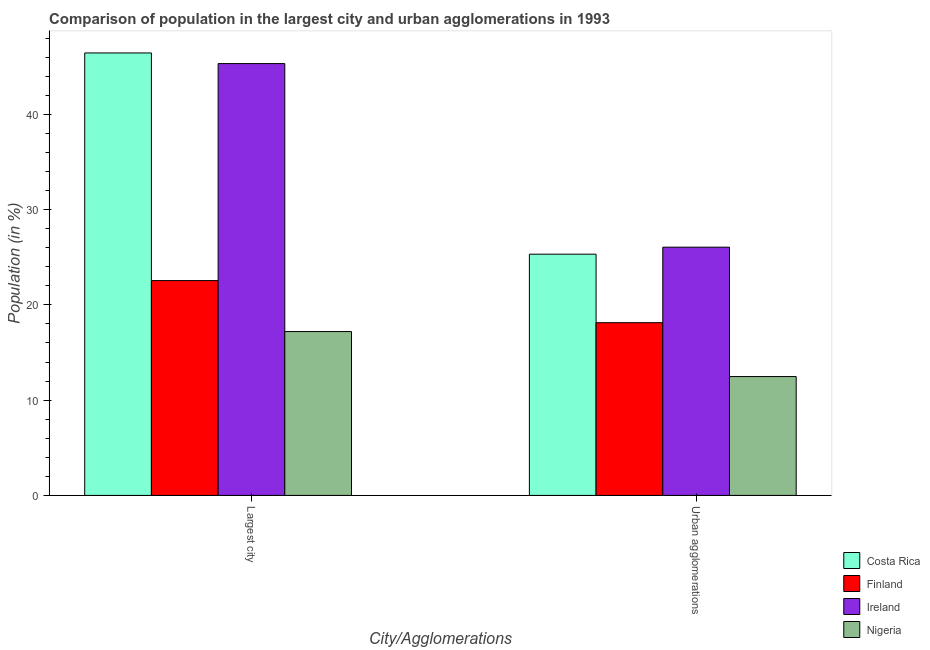How many different coloured bars are there?
Your answer should be very brief. 4. How many groups of bars are there?
Your response must be concise. 2. Are the number of bars on each tick of the X-axis equal?
Offer a very short reply. Yes. How many bars are there on the 1st tick from the right?
Keep it short and to the point. 4. What is the label of the 1st group of bars from the left?
Keep it short and to the point. Largest city. What is the population in urban agglomerations in Ireland?
Provide a short and direct response. 26.05. Across all countries, what is the maximum population in the largest city?
Ensure brevity in your answer.  46.43. Across all countries, what is the minimum population in urban agglomerations?
Make the answer very short. 12.47. In which country was the population in urban agglomerations maximum?
Your response must be concise. Ireland. In which country was the population in urban agglomerations minimum?
Provide a short and direct response. Nigeria. What is the total population in the largest city in the graph?
Give a very brief answer. 131.5. What is the difference between the population in the largest city in Costa Rica and that in Ireland?
Offer a terse response. 1.12. What is the difference between the population in urban agglomerations in Costa Rica and the population in the largest city in Nigeria?
Ensure brevity in your answer.  8.12. What is the average population in the largest city per country?
Offer a very short reply. 32.87. What is the difference between the population in the largest city and population in urban agglomerations in Ireland?
Your answer should be compact. 19.27. What is the ratio of the population in the largest city in Ireland to that in Nigeria?
Your answer should be compact. 2.64. In how many countries, is the population in the largest city greater than the average population in the largest city taken over all countries?
Provide a succinct answer. 2. What does the 4th bar from the left in Largest city represents?
Make the answer very short. Nigeria. What does the 4th bar from the right in Largest city represents?
Ensure brevity in your answer.  Costa Rica. Are all the bars in the graph horizontal?
Your answer should be very brief. No. What is the difference between two consecutive major ticks on the Y-axis?
Your response must be concise. 10. Does the graph contain grids?
Give a very brief answer. No. Where does the legend appear in the graph?
Your answer should be compact. Bottom right. How many legend labels are there?
Provide a succinct answer. 4. How are the legend labels stacked?
Your response must be concise. Vertical. What is the title of the graph?
Provide a succinct answer. Comparison of population in the largest city and urban agglomerations in 1993. What is the label or title of the X-axis?
Your response must be concise. City/Agglomerations. What is the label or title of the Y-axis?
Give a very brief answer. Population (in %). What is the Population (in %) in Costa Rica in Largest city?
Provide a succinct answer. 46.43. What is the Population (in %) of Finland in Largest city?
Give a very brief answer. 22.55. What is the Population (in %) in Ireland in Largest city?
Ensure brevity in your answer.  45.32. What is the Population (in %) of Nigeria in Largest city?
Your answer should be compact. 17.2. What is the Population (in %) of Costa Rica in Urban agglomerations?
Ensure brevity in your answer.  25.32. What is the Population (in %) of Finland in Urban agglomerations?
Your answer should be compact. 18.13. What is the Population (in %) in Ireland in Urban agglomerations?
Your response must be concise. 26.05. What is the Population (in %) of Nigeria in Urban agglomerations?
Provide a succinct answer. 12.47. Across all City/Agglomerations, what is the maximum Population (in %) of Costa Rica?
Offer a very short reply. 46.43. Across all City/Agglomerations, what is the maximum Population (in %) of Finland?
Provide a succinct answer. 22.55. Across all City/Agglomerations, what is the maximum Population (in %) of Ireland?
Offer a very short reply. 45.32. Across all City/Agglomerations, what is the maximum Population (in %) in Nigeria?
Provide a short and direct response. 17.2. Across all City/Agglomerations, what is the minimum Population (in %) of Costa Rica?
Your response must be concise. 25.32. Across all City/Agglomerations, what is the minimum Population (in %) in Finland?
Your answer should be very brief. 18.13. Across all City/Agglomerations, what is the minimum Population (in %) of Ireland?
Your answer should be very brief. 26.05. Across all City/Agglomerations, what is the minimum Population (in %) in Nigeria?
Keep it short and to the point. 12.47. What is the total Population (in %) in Costa Rica in the graph?
Ensure brevity in your answer.  71.75. What is the total Population (in %) in Finland in the graph?
Offer a terse response. 40.67. What is the total Population (in %) in Ireland in the graph?
Your answer should be compact. 71.37. What is the total Population (in %) in Nigeria in the graph?
Your response must be concise. 29.67. What is the difference between the Population (in %) of Costa Rica in Largest city and that in Urban agglomerations?
Keep it short and to the point. 21.12. What is the difference between the Population (in %) of Finland in Largest city and that in Urban agglomerations?
Offer a very short reply. 4.42. What is the difference between the Population (in %) of Ireland in Largest city and that in Urban agglomerations?
Offer a terse response. 19.27. What is the difference between the Population (in %) in Nigeria in Largest city and that in Urban agglomerations?
Your response must be concise. 4.72. What is the difference between the Population (in %) in Costa Rica in Largest city and the Population (in %) in Finland in Urban agglomerations?
Your response must be concise. 28.31. What is the difference between the Population (in %) in Costa Rica in Largest city and the Population (in %) in Ireland in Urban agglomerations?
Offer a terse response. 20.38. What is the difference between the Population (in %) of Costa Rica in Largest city and the Population (in %) of Nigeria in Urban agglomerations?
Offer a terse response. 33.96. What is the difference between the Population (in %) of Finland in Largest city and the Population (in %) of Ireland in Urban agglomerations?
Your answer should be compact. -3.51. What is the difference between the Population (in %) of Finland in Largest city and the Population (in %) of Nigeria in Urban agglomerations?
Your answer should be very brief. 10.07. What is the difference between the Population (in %) of Ireland in Largest city and the Population (in %) of Nigeria in Urban agglomerations?
Make the answer very short. 32.84. What is the average Population (in %) of Costa Rica per City/Agglomerations?
Your answer should be compact. 35.88. What is the average Population (in %) in Finland per City/Agglomerations?
Ensure brevity in your answer.  20.34. What is the average Population (in %) of Ireland per City/Agglomerations?
Offer a very short reply. 35.68. What is the average Population (in %) of Nigeria per City/Agglomerations?
Your response must be concise. 14.84. What is the difference between the Population (in %) in Costa Rica and Population (in %) in Finland in Largest city?
Ensure brevity in your answer.  23.89. What is the difference between the Population (in %) of Costa Rica and Population (in %) of Ireland in Largest city?
Give a very brief answer. 1.12. What is the difference between the Population (in %) in Costa Rica and Population (in %) in Nigeria in Largest city?
Provide a short and direct response. 29.24. What is the difference between the Population (in %) of Finland and Population (in %) of Ireland in Largest city?
Offer a terse response. -22.77. What is the difference between the Population (in %) in Finland and Population (in %) in Nigeria in Largest city?
Provide a short and direct response. 5.35. What is the difference between the Population (in %) in Ireland and Population (in %) in Nigeria in Largest city?
Ensure brevity in your answer.  28.12. What is the difference between the Population (in %) in Costa Rica and Population (in %) in Finland in Urban agglomerations?
Give a very brief answer. 7.19. What is the difference between the Population (in %) of Costa Rica and Population (in %) of Ireland in Urban agglomerations?
Keep it short and to the point. -0.73. What is the difference between the Population (in %) of Costa Rica and Population (in %) of Nigeria in Urban agglomerations?
Your answer should be very brief. 12.84. What is the difference between the Population (in %) in Finland and Population (in %) in Ireland in Urban agglomerations?
Provide a succinct answer. -7.92. What is the difference between the Population (in %) in Finland and Population (in %) in Nigeria in Urban agglomerations?
Offer a terse response. 5.65. What is the difference between the Population (in %) of Ireland and Population (in %) of Nigeria in Urban agglomerations?
Offer a terse response. 13.58. What is the ratio of the Population (in %) of Costa Rica in Largest city to that in Urban agglomerations?
Offer a terse response. 1.83. What is the ratio of the Population (in %) of Finland in Largest city to that in Urban agglomerations?
Keep it short and to the point. 1.24. What is the ratio of the Population (in %) in Ireland in Largest city to that in Urban agglomerations?
Your answer should be very brief. 1.74. What is the ratio of the Population (in %) in Nigeria in Largest city to that in Urban agglomerations?
Your answer should be compact. 1.38. What is the difference between the highest and the second highest Population (in %) in Costa Rica?
Ensure brevity in your answer.  21.12. What is the difference between the highest and the second highest Population (in %) of Finland?
Provide a short and direct response. 4.42. What is the difference between the highest and the second highest Population (in %) in Ireland?
Give a very brief answer. 19.27. What is the difference between the highest and the second highest Population (in %) of Nigeria?
Your answer should be compact. 4.72. What is the difference between the highest and the lowest Population (in %) in Costa Rica?
Your response must be concise. 21.12. What is the difference between the highest and the lowest Population (in %) of Finland?
Give a very brief answer. 4.42. What is the difference between the highest and the lowest Population (in %) of Ireland?
Your answer should be compact. 19.27. What is the difference between the highest and the lowest Population (in %) of Nigeria?
Provide a succinct answer. 4.72. 